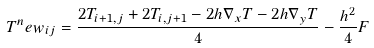Convert formula to latex. <formula><loc_0><loc_0><loc_500><loc_500>T ^ { n } e w _ { i j } = \frac { 2 T _ { i + 1 , j } + 2 T _ { i , j + 1 } - 2 h \nabla _ { x } T - 2 h \nabla _ { y } T } { 4 } - \frac { h ^ { 2 } } { 4 } F</formula> 